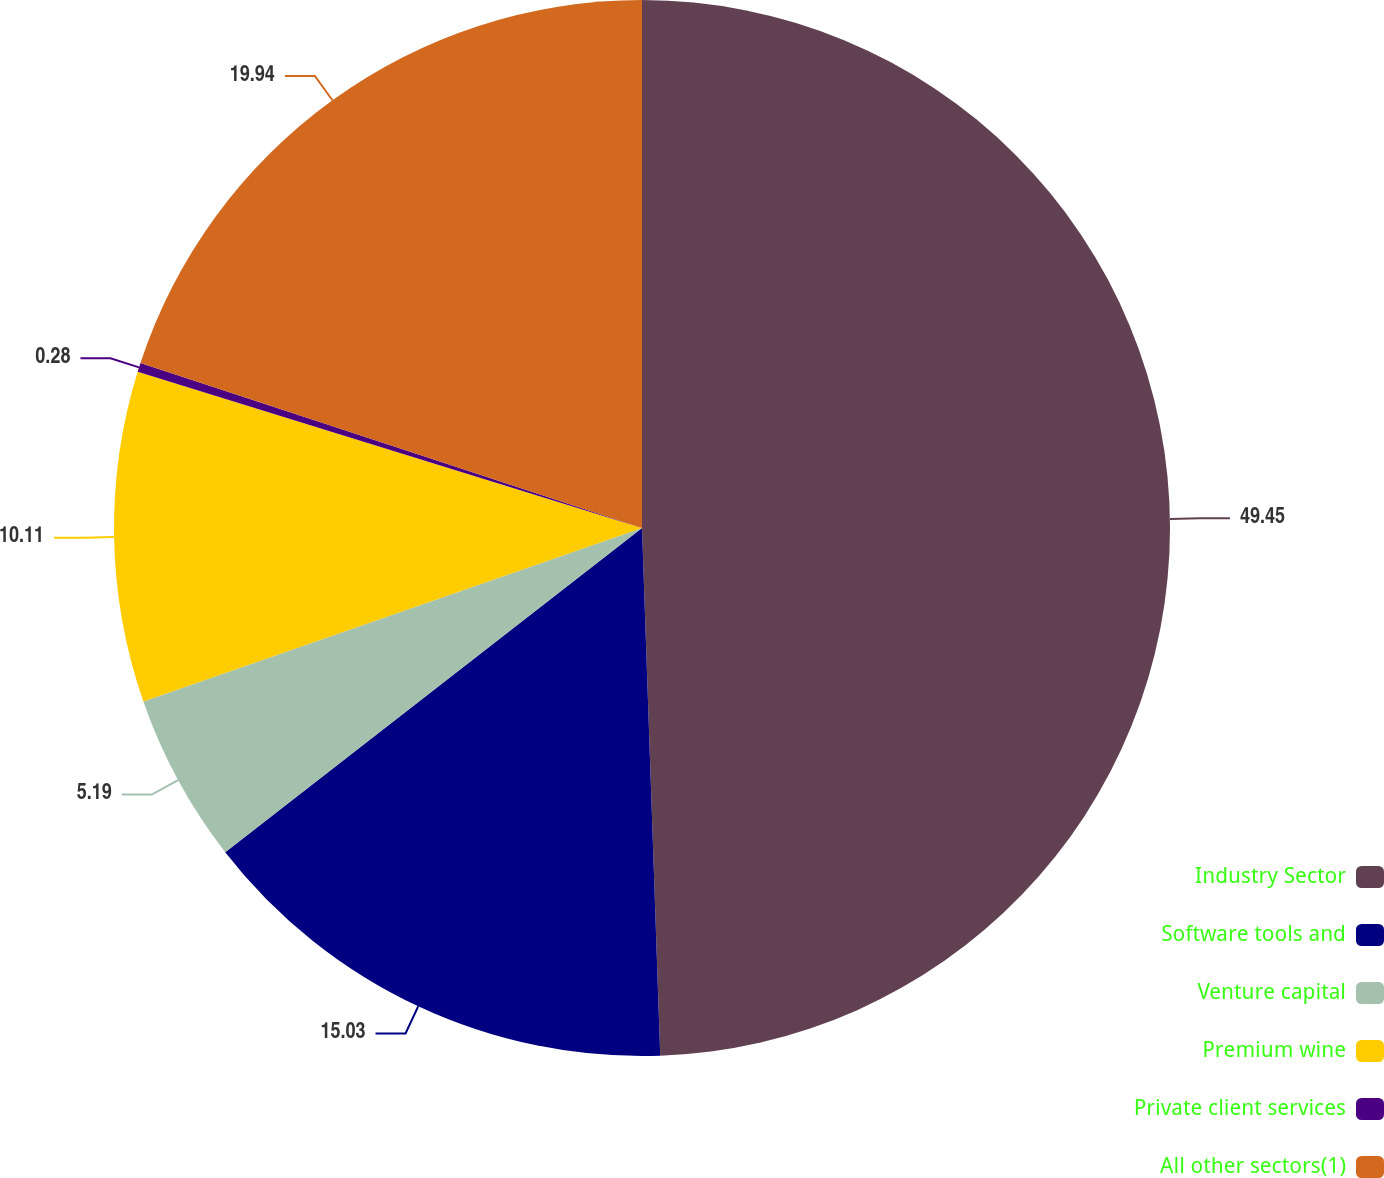<chart> <loc_0><loc_0><loc_500><loc_500><pie_chart><fcel>Industry Sector<fcel>Software tools and<fcel>Venture capital<fcel>Premium wine<fcel>Private client services<fcel>All other sectors(1)<nl><fcel>49.45%<fcel>15.03%<fcel>5.19%<fcel>10.11%<fcel>0.28%<fcel>19.94%<nl></chart> 